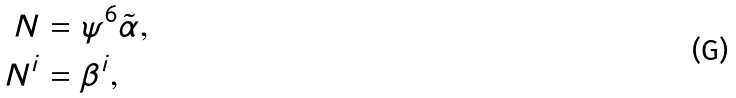<formula> <loc_0><loc_0><loc_500><loc_500>N & = \psi ^ { 6 } \tilde { \alpha } , \\ N ^ { i } & = \beta ^ { i } ,</formula> 